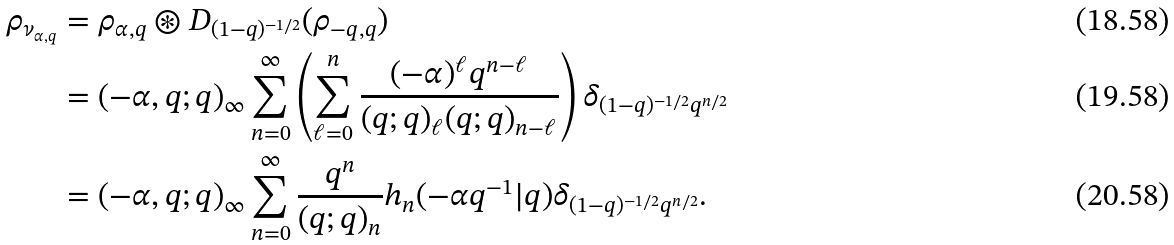Convert formula to latex. <formula><loc_0><loc_0><loc_500><loc_500>\rho _ { \nu _ { \alpha , q } } & = \rho _ { \alpha , q } \circledast D _ { ( 1 - q ) ^ { - 1 / 2 } } ( \rho _ { - q , q } ) \\ & = ( - \alpha , q ; q ) _ { \infty } \sum _ { n = 0 } ^ { \infty } \left ( \sum _ { \ell = 0 } ^ { n } \frac { ( - \alpha ) ^ { \ell } q ^ { n - \ell } } { ( q ; q ) _ { \ell } ( q ; q ) _ { n - \ell } } \right ) \delta _ { ( 1 - q ) ^ { - 1 / 2 } q ^ { n / 2 } } \\ & = ( - \alpha , q ; q ) _ { \infty } \sum _ { n = 0 } ^ { \infty } \frac { q ^ { n } } { ( q ; q ) _ { n } } h _ { n } ( - \alpha q ^ { - 1 } | q ) \delta _ { ( 1 - q ) ^ { - 1 / 2 } q ^ { n / 2 } } .</formula> 